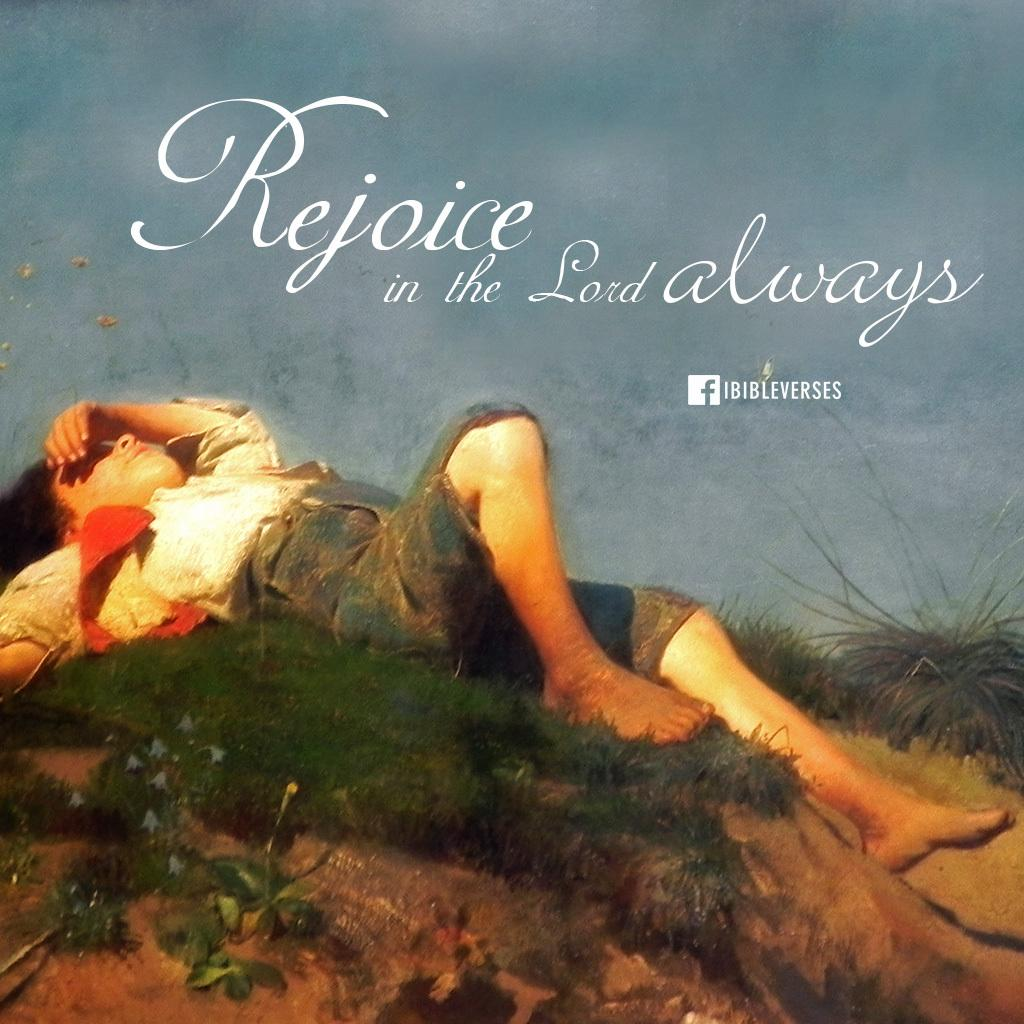<image>
Render a clear and concise summary of the photo. A religious photo that reads Rejoice in the lord always. 